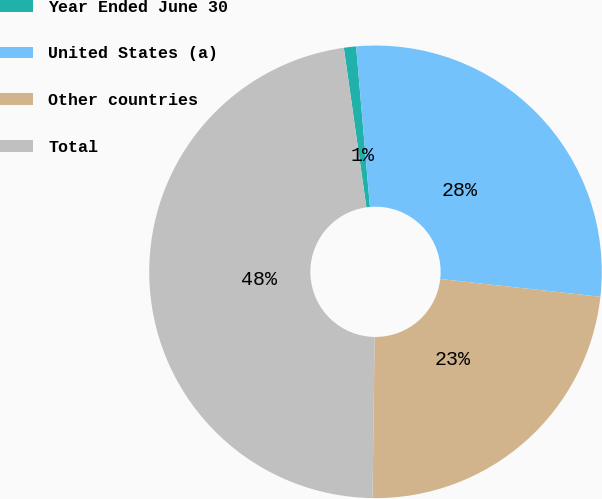Convert chart to OTSL. <chart><loc_0><loc_0><loc_500><loc_500><pie_chart><fcel>Year Ended June 30<fcel>United States (a)<fcel>Other countries<fcel>Total<nl><fcel>0.87%<fcel>28.12%<fcel>23.45%<fcel>47.55%<nl></chart> 